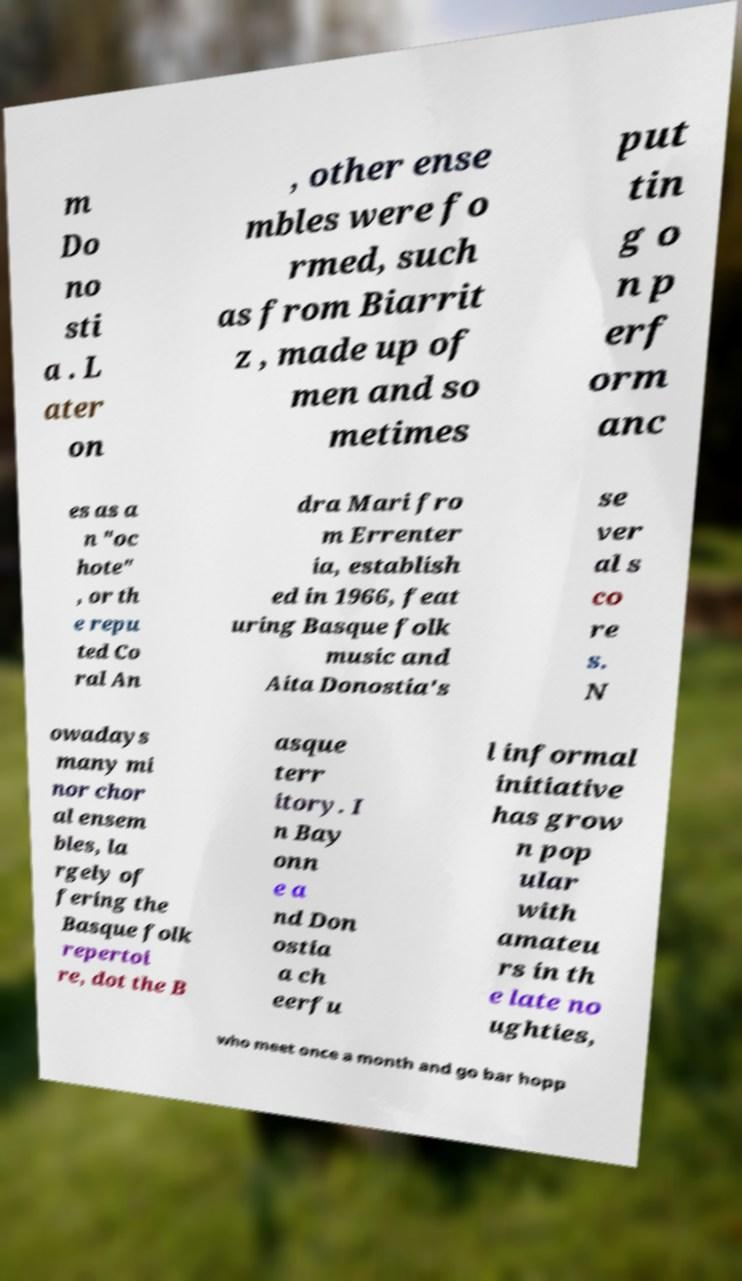Can you read and provide the text displayed in the image?This photo seems to have some interesting text. Can you extract and type it out for me? m Do no sti a . L ater on , other ense mbles were fo rmed, such as from Biarrit z , made up of men and so metimes put tin g o n p erf orm anc es as a n "oc hote" , or th e repu ted Co ral An dra Mari fro m Errenter ia, establish ed in 1966, feat uring Basque folk music and Aita Donostia's se ver al s co re s. N owadays many mi nor chor al ensem bles, la rgely of fering the Basque folk repertoi re, dot the B asque terr itory. I n Bay onn e a nd Don ostia a ch eerfu l informal initiative has grow n pop ular with amateu rs in th e late no ughties, who meet once a month and go bar hopp 